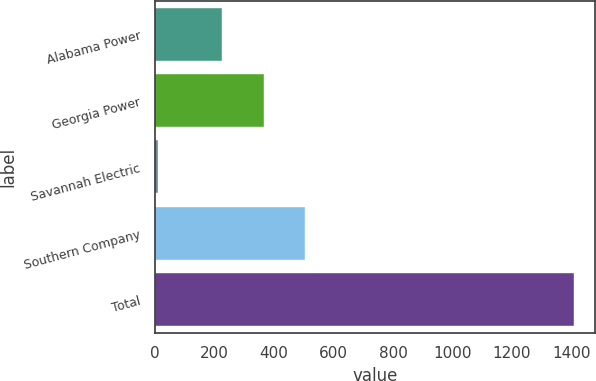<chart> <loc_0><loc_0><loc_500><loc_500><bar_chart><fcel>Alabama Power<fcel>Georgia Power<fcel>Savannah Electric<fcel>Southern Company<fcel>Total<nl><fcel>225<fcel>365<fcel>10<fcel>505<fcel>1410<nl></chart> 